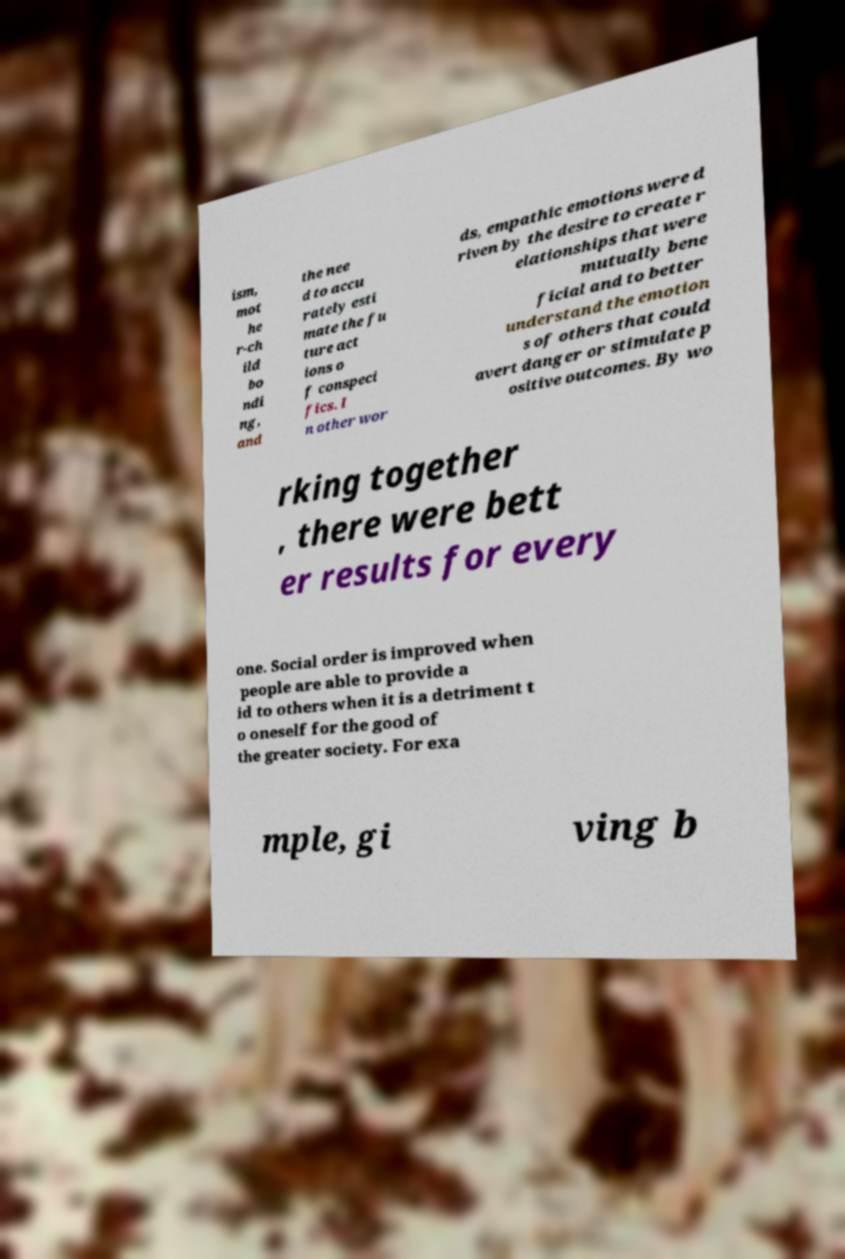What messages or text are displayed in this image? I need them in a readable, typed format. ism, mot he r-ch ild bo ndi ng, and the nee d to accu rately esti mate the fu ture act ions o f conspeci fics. I n other wor ds, empathic emotions were d riven by the desire to create r elationships that were mutually bene ficial and to better understand the emotion s of others that could avert danger or stimulate p ositive outcomes. By wo rking together , there were bett er results for every one. Social order is improved when people are able to provide a id to others when it is a detriment t o oneself for the good of the greater society. For exa mple, gi ving b 